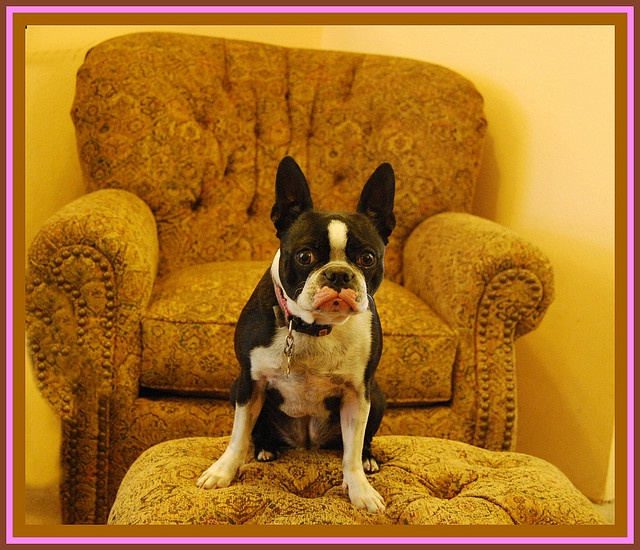Describe the objects in this image and their specific colors. I can see couch in brown, red, maroon, and orange tones and dog in brown, black, olive, maroon, and tan tones in this image. 